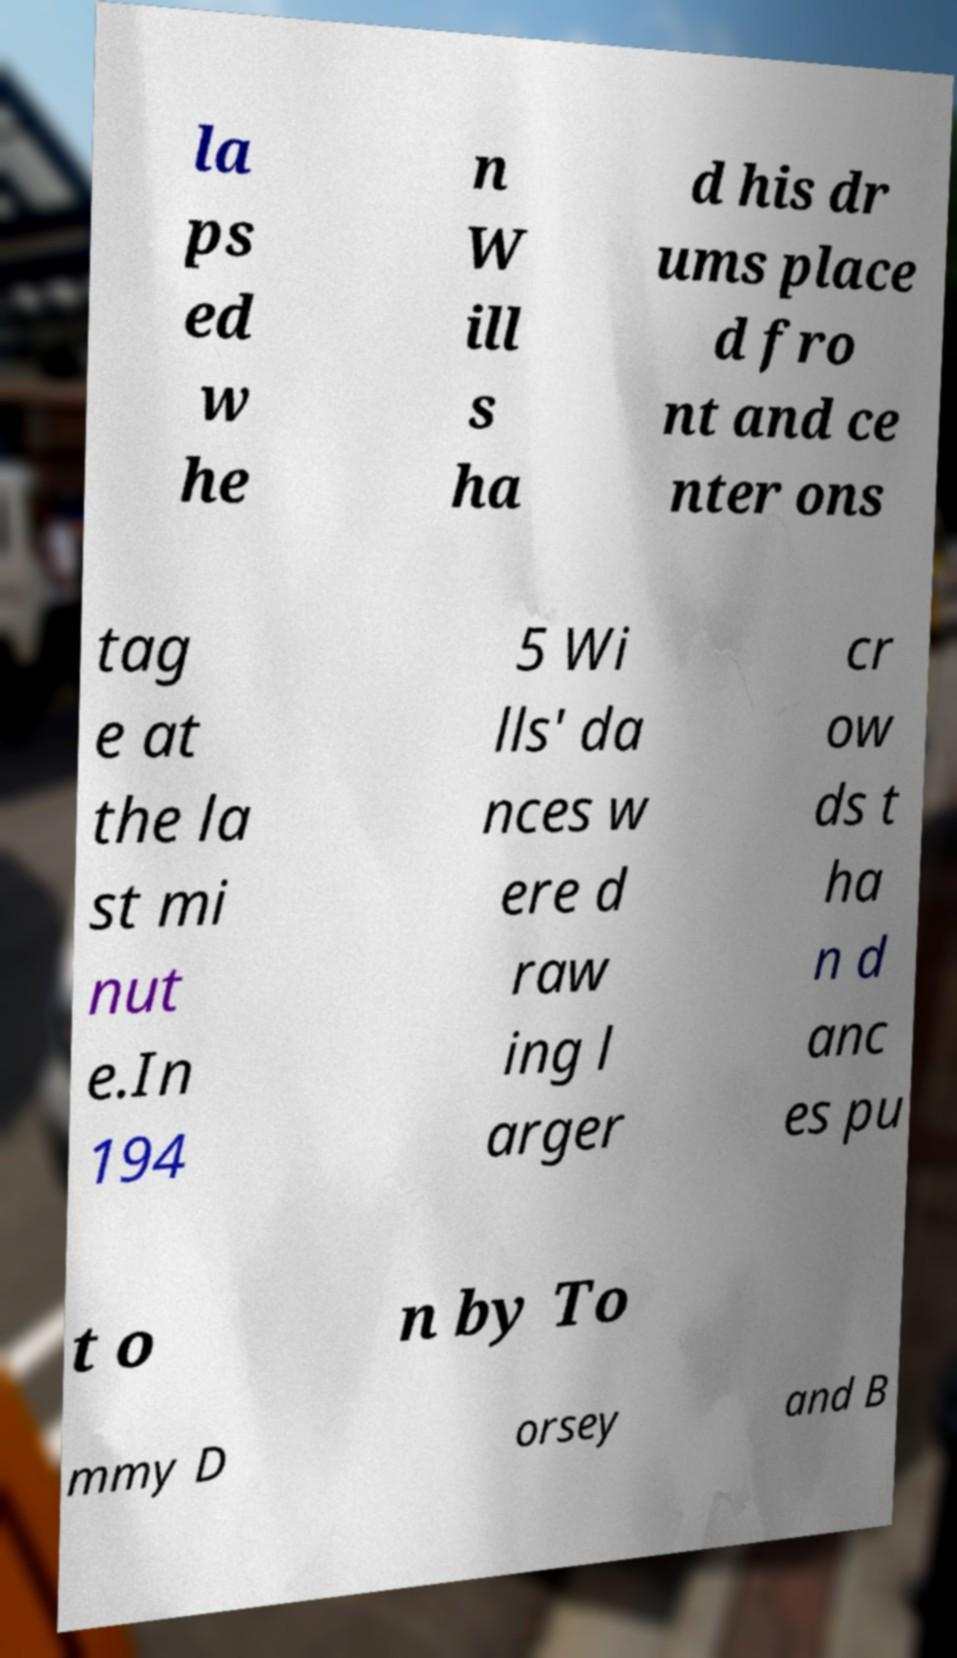Could you assist in decoding the text presented in this image and type it out clearly? la ps ed w he n W ill s ha d his dr ums place d fro nt and ce nter ons tag e at the la st mi nut e.In 194 5 Wi lls' da nces w ere d raw ing l arger cr ow ds t ha n d anc es pu t o n by To mmy D orsey and B 